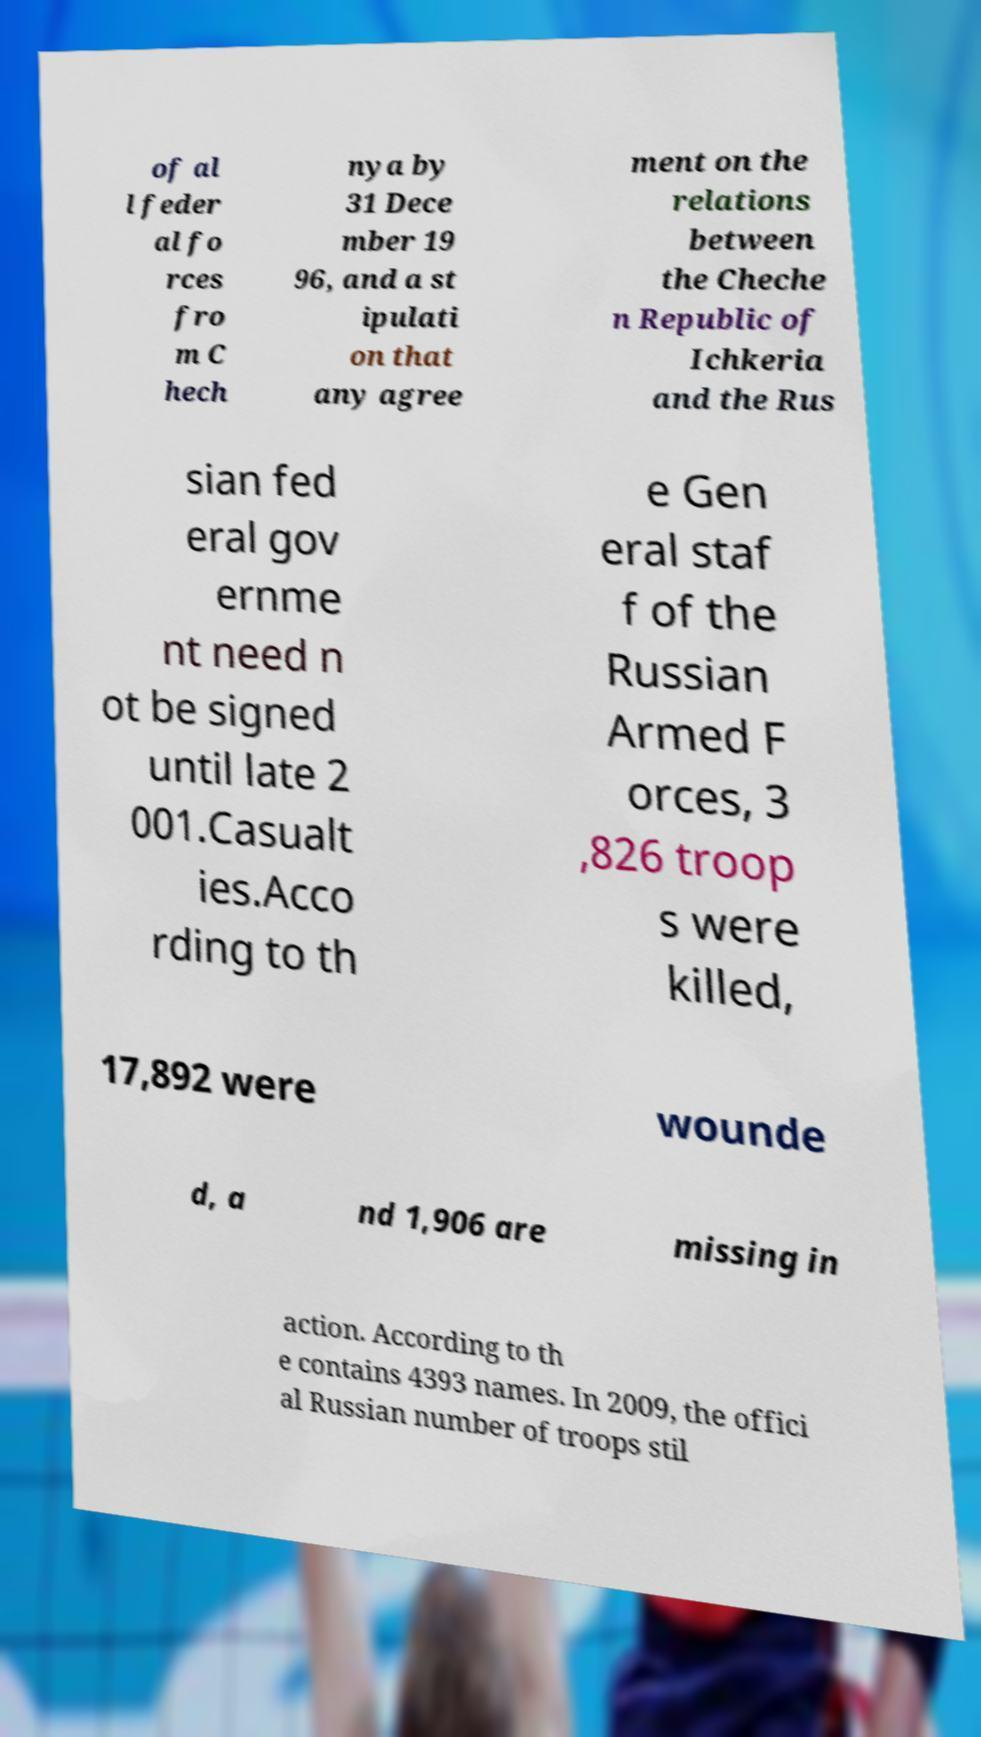I need the written content from this picture converted into text. Can you do that? of al l feder al fo rces fro m C hech nya by 31 Dece mber 19 96, and a st ipulati on that any agree ment on the relations between the Cheche n Republic of Ichkeria and the Rus sian fed eral gov ernme nt need n ot be signed until late 2 001.Casualt ies.Acco rding to th e Gen eral staf f of the Russian Armed F orces, 3 ,826 troop s were killed, 17,892 were wounde d, a nd 1,906 are missing in action. According to th e contains 4393 names. In 2009, the offici al Russian number of troops stil 